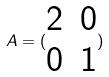<formula> <loc_0><loc_0><loc_500><loc_500>A = ( \begin{matrix} 2 & 0 \\ 0 & 1 \end{matrix} )</formula> 